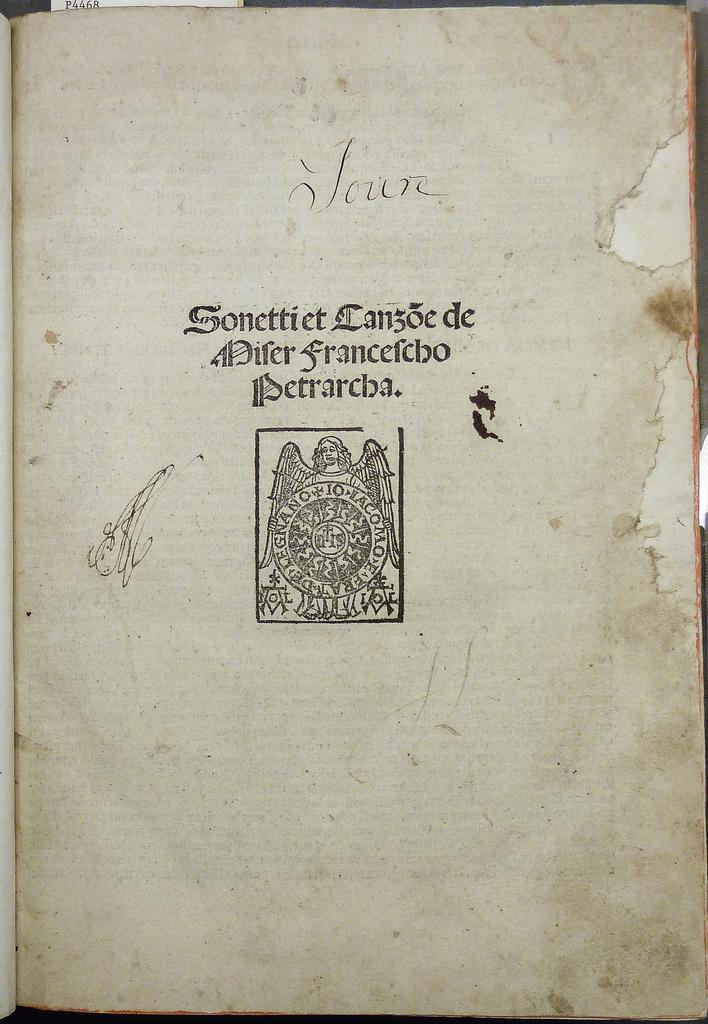What is present in the image? There is a book in the image. What can be found inside the book? There is text in the book. What type of image is depicted in the book? There is a picture of a person with wings in the book. What is the person with wings doing in the picture? The person with wings is holding an object in the picture. How many bikes are visible in the picture of the person with wings? There are no bikes visible in the picture of the person with wings; the image only shows a person with wings holding an object. 